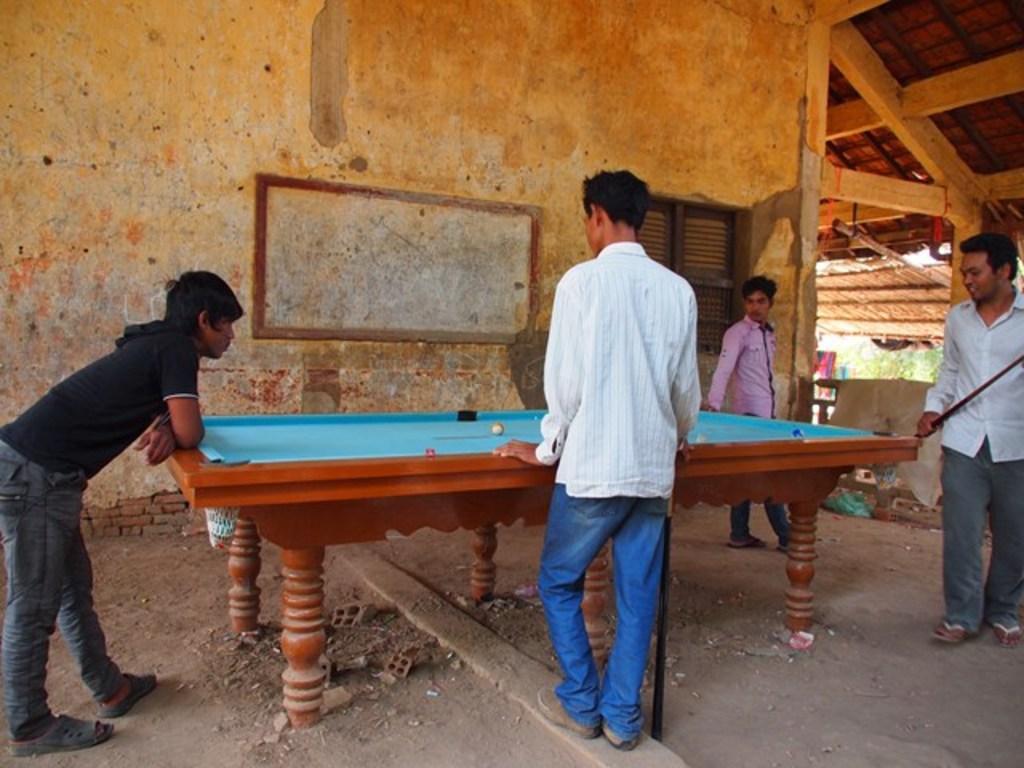Please provide a concise description of this image. In this image, we can see a snooker table with balls on the surface. We can see four persons around the table. On the right side of the image, a person holding a stick and walking. In the background, we can see the wall, board, window, clothes, pillars, trees and few objects.  